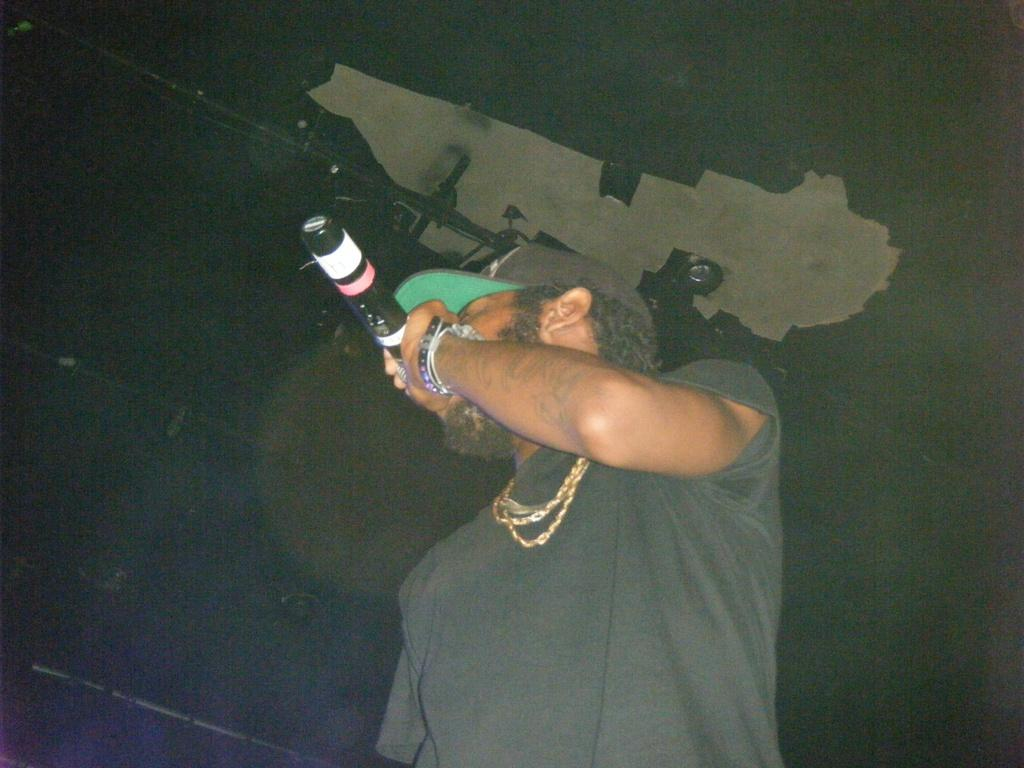What is the person in the image doing? The person is standing in the image and holding a microphone. What might the person be doing with the microphone? The person might be using the microphone for speaking or singing. What can be seen attached to the ceiling in the image? There are objects attached to the ceiling in the image, but their specific nature is not mentioned in the facts. What can be seen attached to the wall in the image? There are objects attached to the wall in the image, but their specific nature is not mentioned in the facts. What type of harmony is being played by the person wearing a sweater in the image? There is no person wearing a sweater in the image, and no mention of harmony being played. 